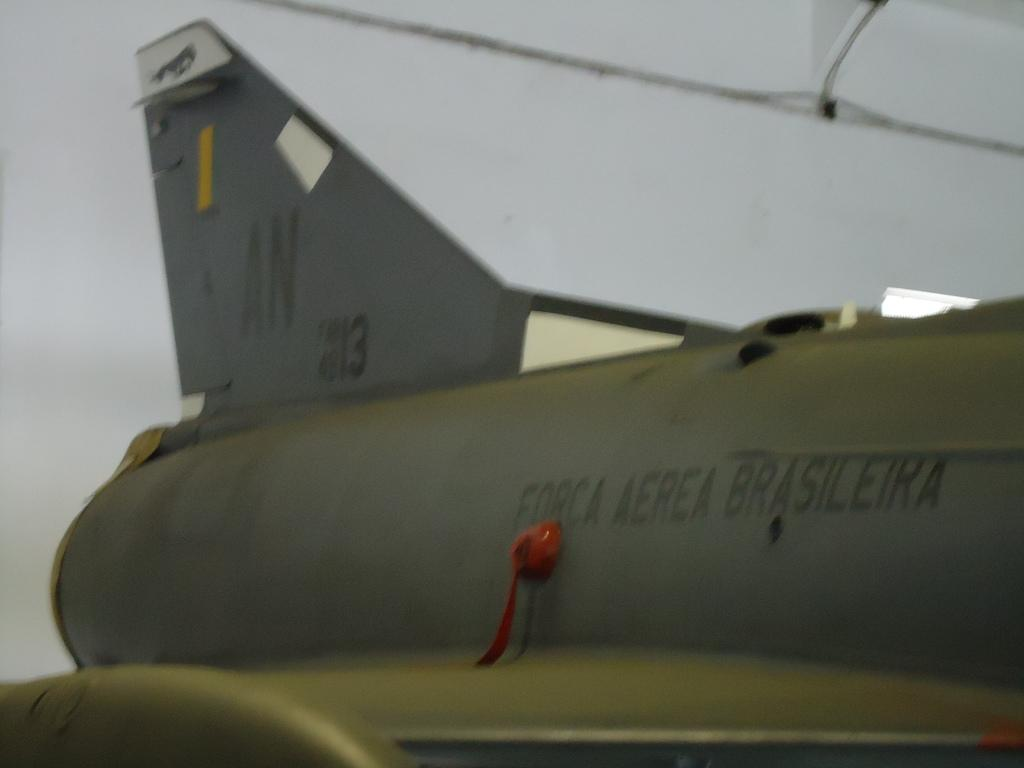<image>
Relay a brief, clear account of the picture shown. An airplane with AN 13 on the tail is painted a flat gray color. 